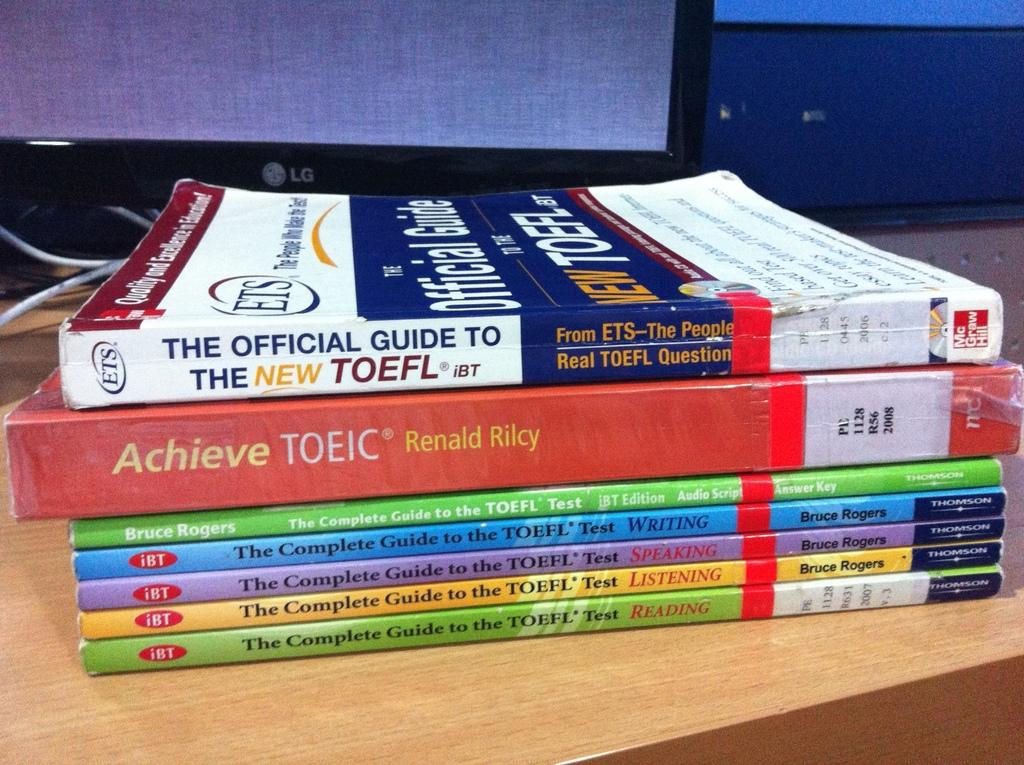<image>
Provide a brief description of the given image. The TOEFL test can be prepared for using specialized study books. 